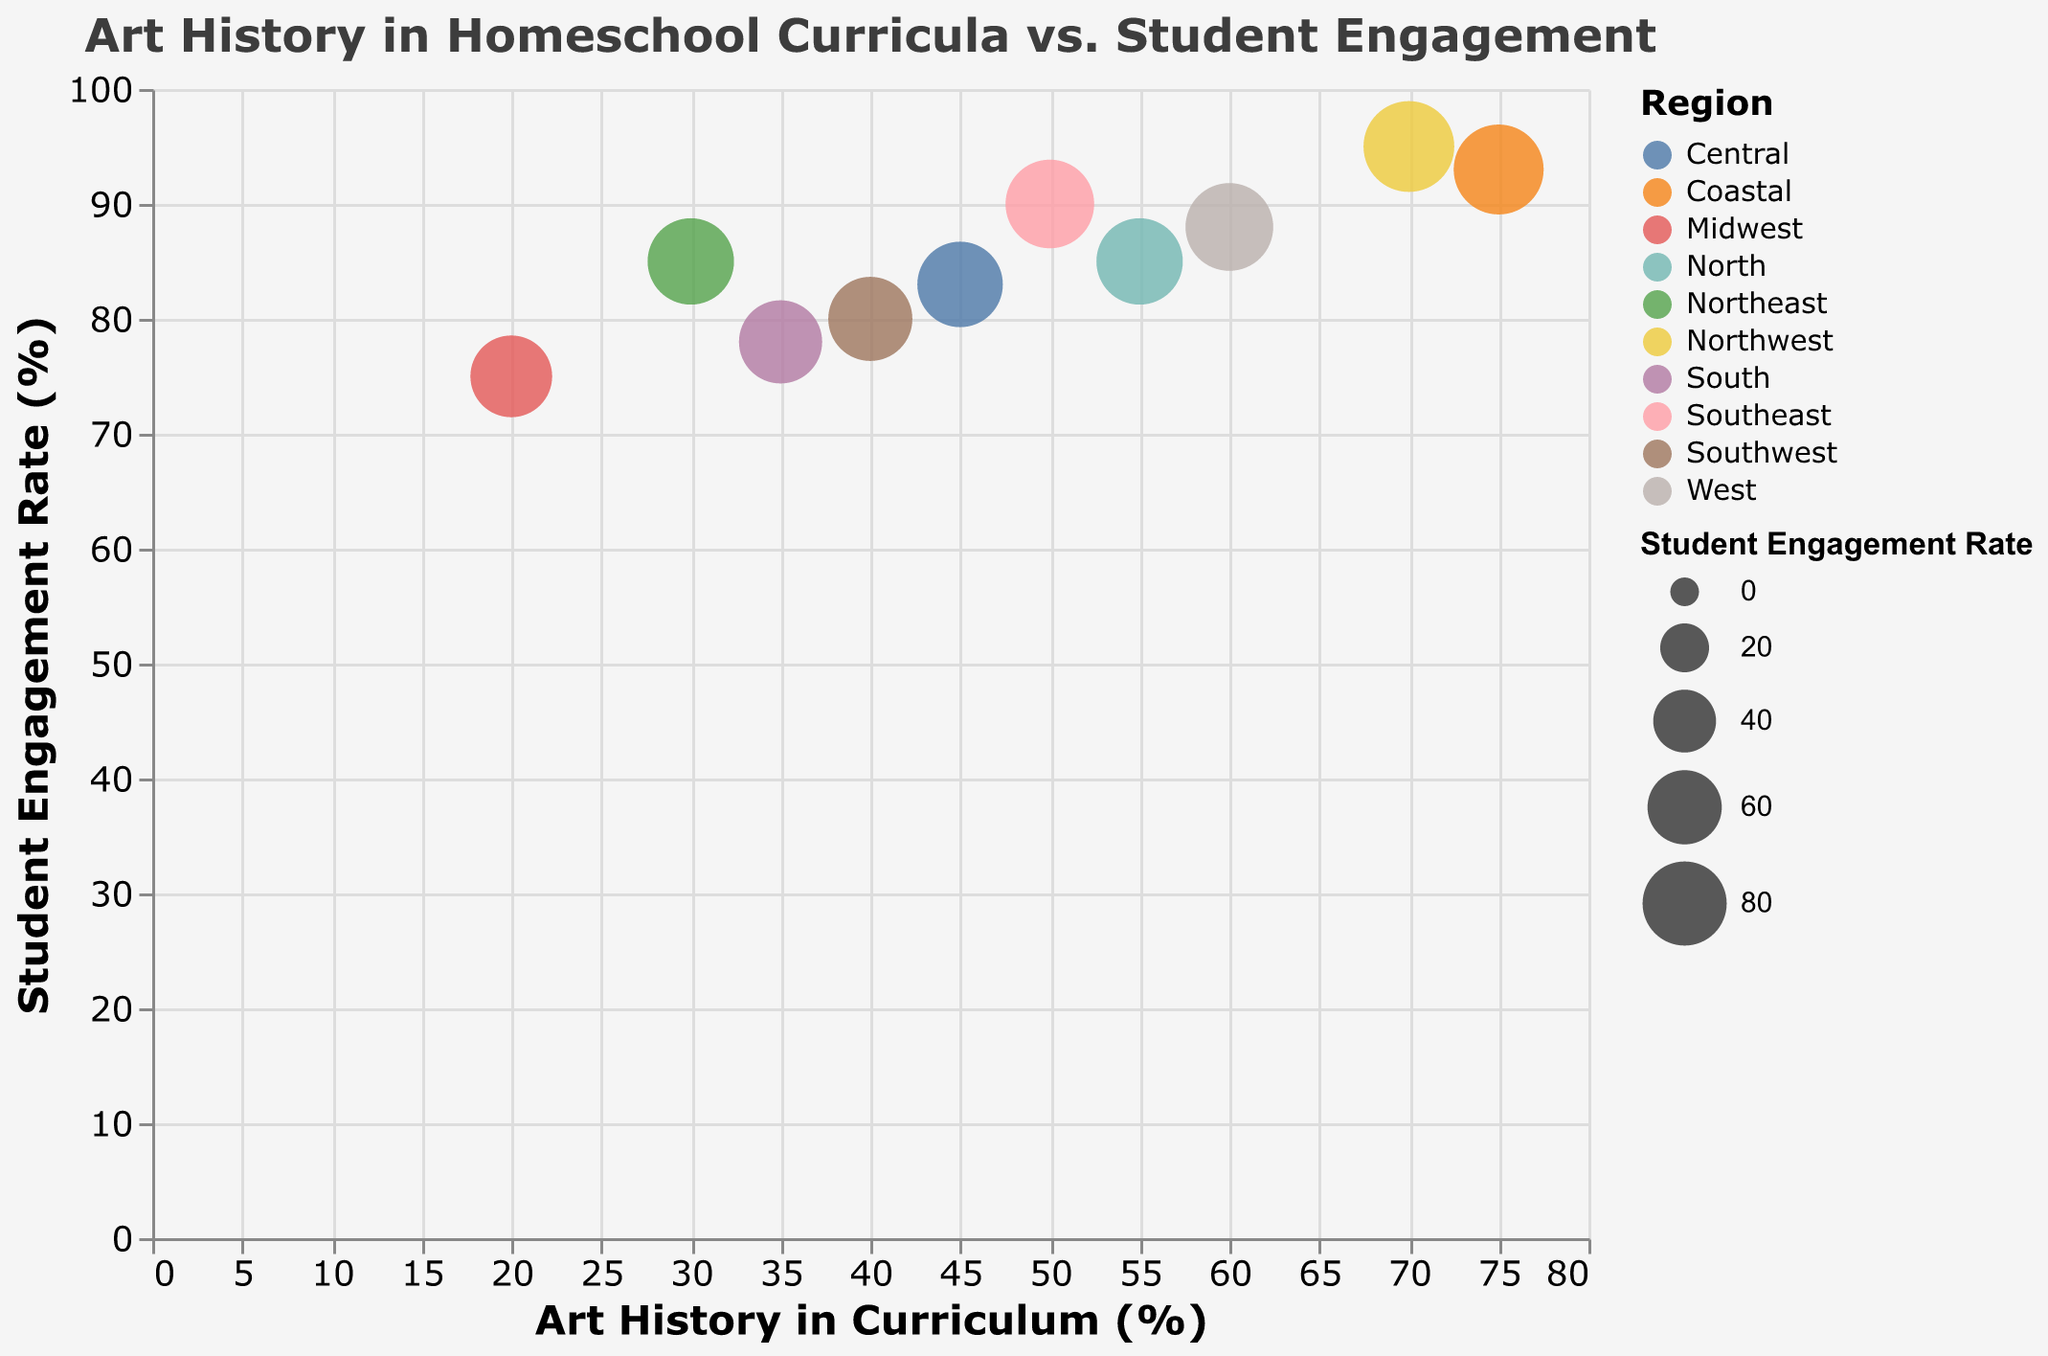What's the title of the figure? The title is displayed at the top of the figure.
Answer: Art History in Homeschool Curricula vs. Student Engagement Which institution has the highest Student Engagement Rate? By looking at the y-axis and identifying the topmost bubble, we can see that Riverside Learning Home Education System has the highest engagement rate.
Answer: Riverside Learning Home Education System Which region is represented by the color that includes the largest bubble? The largest bubble is determined by its size, which in this case is for Riverside Learning Home Education System. The color of this bubble represents the Northwest region.
Answer: Northwest How many institutions have a Student Engagement Rate greater than 85%? Locate the bubbles above the 85% mark on the y-axis and count them. The institutions are Horizon Academy Homeschool Program, Riverside Learning Home Education System, Silver Oak Homeschool Initiative, Seaside Homeschool Community, and Maple Grove Homeschoolers Association.
Answer: 5 Which region has the most institutions? Count the bubbles for each color. The Northeast, Southeast, Northwest, Midwest, West, Southwest, South, North, Coastal, and Central are unique, hence, no repetition in the region count.
Answer: Every region has 1 institution What's the average percentage of homeschool curricula that include Art History? Add the percentages of Art History inclusion and divide by the number of institutions: (30 + 50 + 70 + 20 + 60 + 40 + 35 + 55 + 75 + 45) / 10 = 48
Answer: 48 Compare the Student Engagement Rates between Acorn Valley Homeschool Co-op and Horizon Academy Homeschool Program. Refer to the y-axis values of the corresponding bubbles to see that Acorn Valley has an 85% engagement rate while Horizon Academy has a 90% engagement rate.
Answer: Acorn Valley: 85%, Horizon Academy: 90% What is the difference in Student Engagement Rates between institutions with the highest and lowest Art History inclusion? The highest inclusion is 75% (Seaside Homeschool Community with 93% engagement) and the lowest is 20% (Evergreen Homeschool Network with 75% engagement). The difference in engagement rates is 93% - 75% = 18%
Answer: 18% What's the Student Engagement Rate for institutions with 55% Art History in their curriculum? Locate the bubble for 55% on the x-axis and refer to its y-axis position. Maple Grove Homeschoolers Association has an 85% engagement rate.
Answer: 85% Which institution located in the Central region has the Student Engagement Rate less than 90%? By identifying the bubble colored for the Central region and analyzing its y-axis position, we see Lakewood Family Schooling Cooperative has an engagement rate of 83%.
Answer: Lakewood Family Schooling Cooperative 